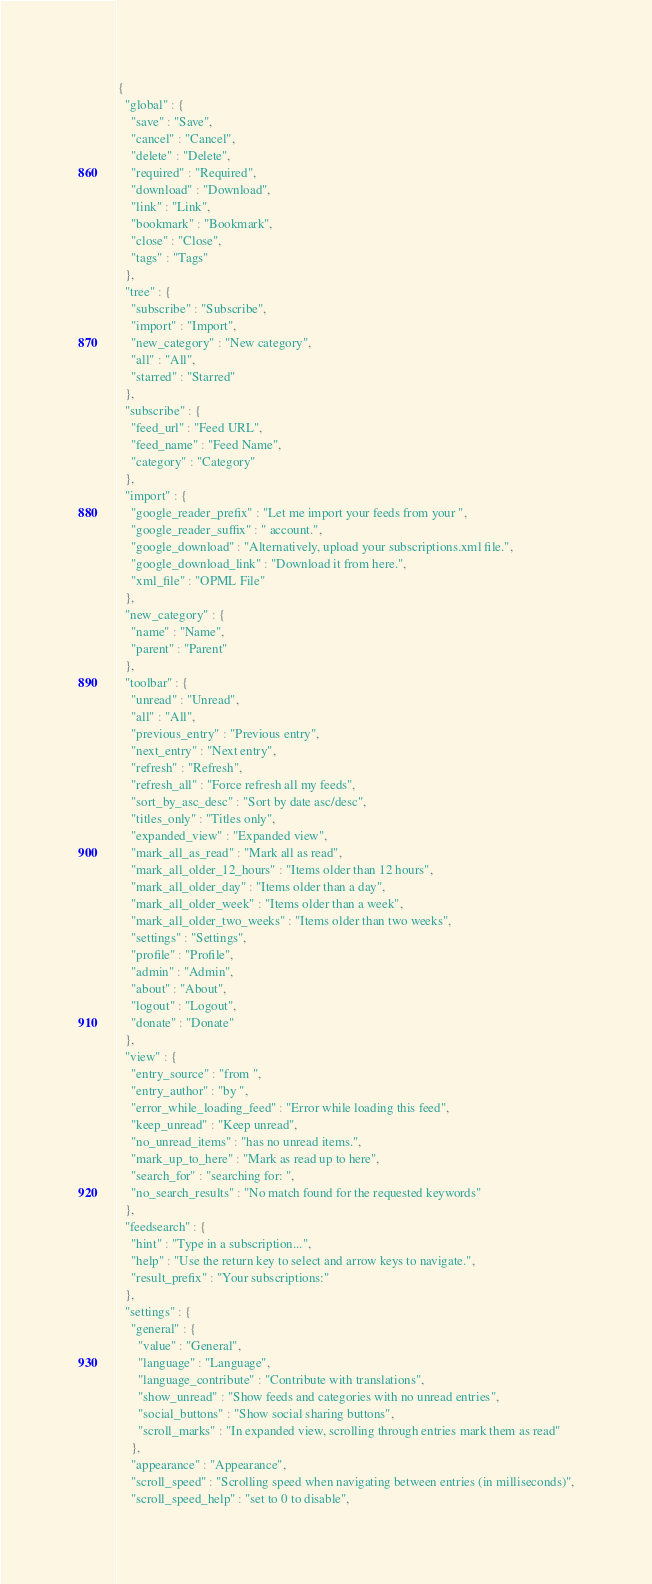<code> <loc_0><loc_0><loc_500><loc_500><_JavaScript_>{
  "global" : {
    "save" : "Save",
    "cancel" : "Cancel",
    "delete" : "Delete",
    "required" : "Required",
    "download" : "Download",
    "link" : "Link",
    "bookmark" : "Bookmark",
    "close" : "Close",
    "tags" : "Tags"
  },
  "tree" : {
    "subscribe" : "Subscribe",
    "import" : "Import",
    "new_category" : "New category",
    "all" : "All",
    "starred" : "Starred"
  },
  "subscribe" : {
    "feed_url" : "Feed URL",
    "feed_name" : "Feed Name",
    "category" : "Category"
  },
  "import" : {
    "google_reader_prefix" : "Let me import your feeds from your ",
    "google_reader_suffix" : " account.",
    "google_download" : "Alternatively, upload your subscriptions.xml file.",
    "google_download_link" : "Download it from here.",
    "xml_file" : "OPML File"
  },
  "new_category" : {
    "name" : "Name",
    "parent" : "Parent"
  },
  "toolbar" : {
    "unread" : "Unread",
    "all" : "All",
    "previous_entry" : "Previous entry",
    "next_entry" : "Next entry",
    "refresh" : "Refresh",
    "refresh_all" : "Force refresh all my feeds",
    "sort_by_asc_desc" : "Sort by date asc/desc",
    "titles_only" : "Titles only",
    "expanded_view" : "Expanded view",
    "mark_all_as_read" : "Mark all as read",
    "mark_all_older_12_hours" : "Items older than 12 hours",
    "mark_all_older_day" : "Items older than a day",
    "mark_all_older_week" : "Items older than a week",
    "mark_all_older_two_weeks" : "Items older than two weeks",
    "settings" : "Settings",
    "profile" : "Profile",
    "admin" : "Admin",
    "about" : "About",
    "logout" : "Logout",
    "donate" : "Donate"
  },
  "view" : {
    "entry_source" : "from ",
    "entry_author" : "by ",
    "error_while_loading_feed" : "Error while loading this feed",
    "keep_unread" : "Keep unread",
    "no_unread_items" : "has no unread items.",
    "mark_up_to_here" : "Mark as read up to here",
    "search_for" : "searching for: ",
    "no_search_results" : "No match found for the requested keywords"
  },
  "feedsearch" : {
    "hint" : "Type in a subscription...",
    "help" : "Use the return key to select and arrow keys to navigate.",
    "result_prefix" : "Your subscriptions:"
  },
  "settings" : {
    "general" : {
      "value" : "General",
      "language" : "Language",
      "language_contribute" : "Contribute with translations",
      "show_unread" : "Show feeds and categories with no unread entries",
      "social_buttons" : "Show social sharing buttons",
      "scroll_marks" : "In expanded view, scrolling through entries mark them as read"
    },
    "appearance" : "Appearance",
    "scroll_speed" : "Scrolling speed when navigating between entries (in milliseconds)",
    "scroll_speed_help" : "set to 0 to disable",</code> 